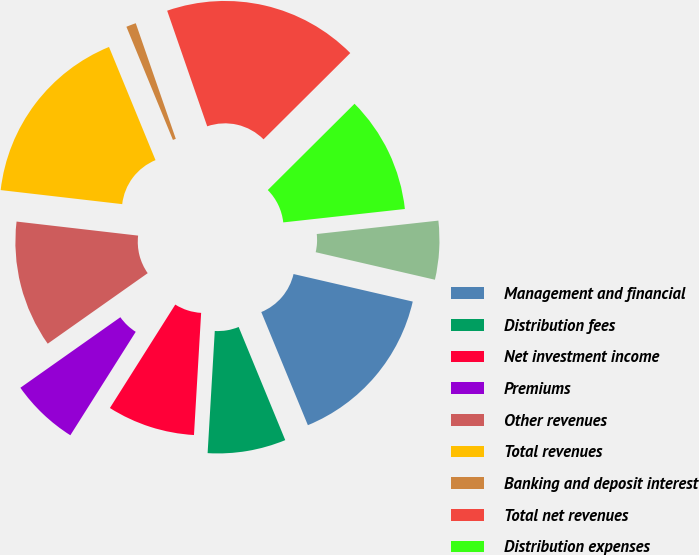<chart> <loc_0><loc_0><loc_500><loc_500><pie_chart><fcel>Management and financial<fcel>Distribution fees<fcel>Net investment income<fcel>Premiums<fcel>Other revenues<fcel>Total revenues<fcel>Banking and deposit interest<fcel>Total net revenues<fcel>Distribution expenses<fcel>Interest credited to fixed<nl><fcel>15.17%<fcel>7.15%<fcel>8.04%<fcel>6.25%<fcel>11.61%<fcel>16.96%<fcel>0.9%<fcel>17.85%<fcel>10.71%<fcel>5.36%<nl></chart> 